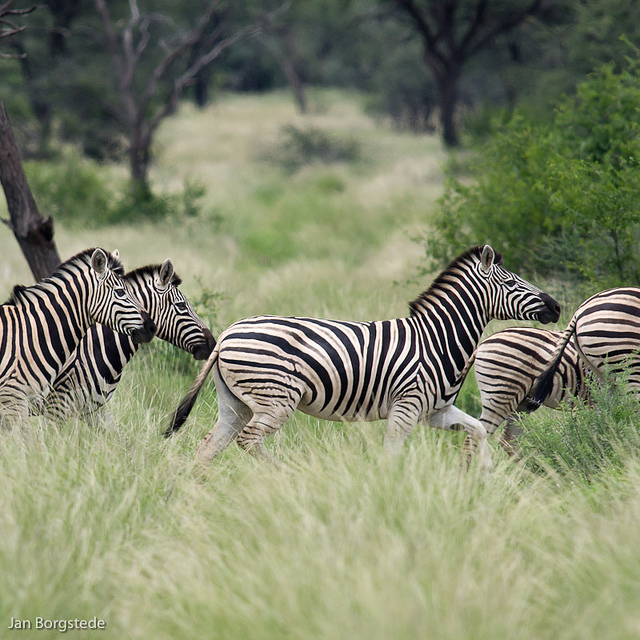Please transcribe the text in this image. Jan Borgstede 